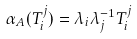Convert formula to latex. <formula><loc_0><loc_0><loc_500><loc_500>\alpha _ { A } ( T _ { i } ^ { j } ) = \lambda _ { i } \lambda _ { j } ^ { - 1 } T _ { i } ^ { j }</formula> 